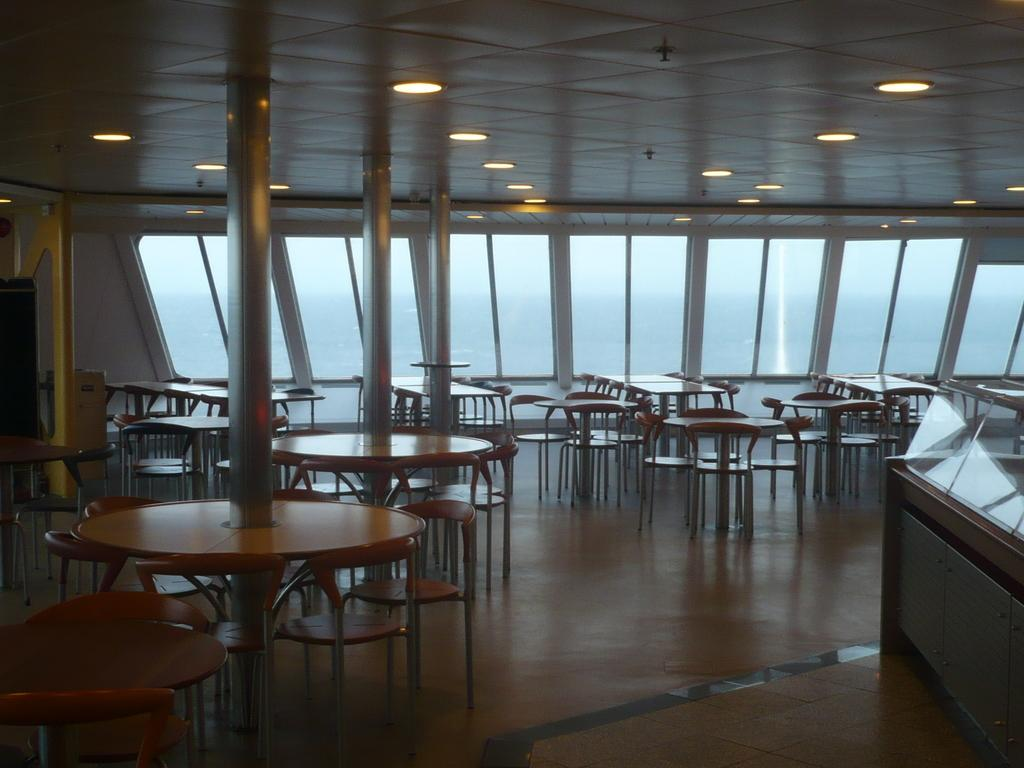What type of location is depicted in the image? The image is an inside view of a restaurant. What furniture is present in the image? There are tables and chairs in the image. Where is the counter located in the image? The counter is on the right side of the image. What type of organization is responsible for the rays of light in the image? There are no rays of light present in the image, so it is not possible to determine which organization might be responsible for them. 